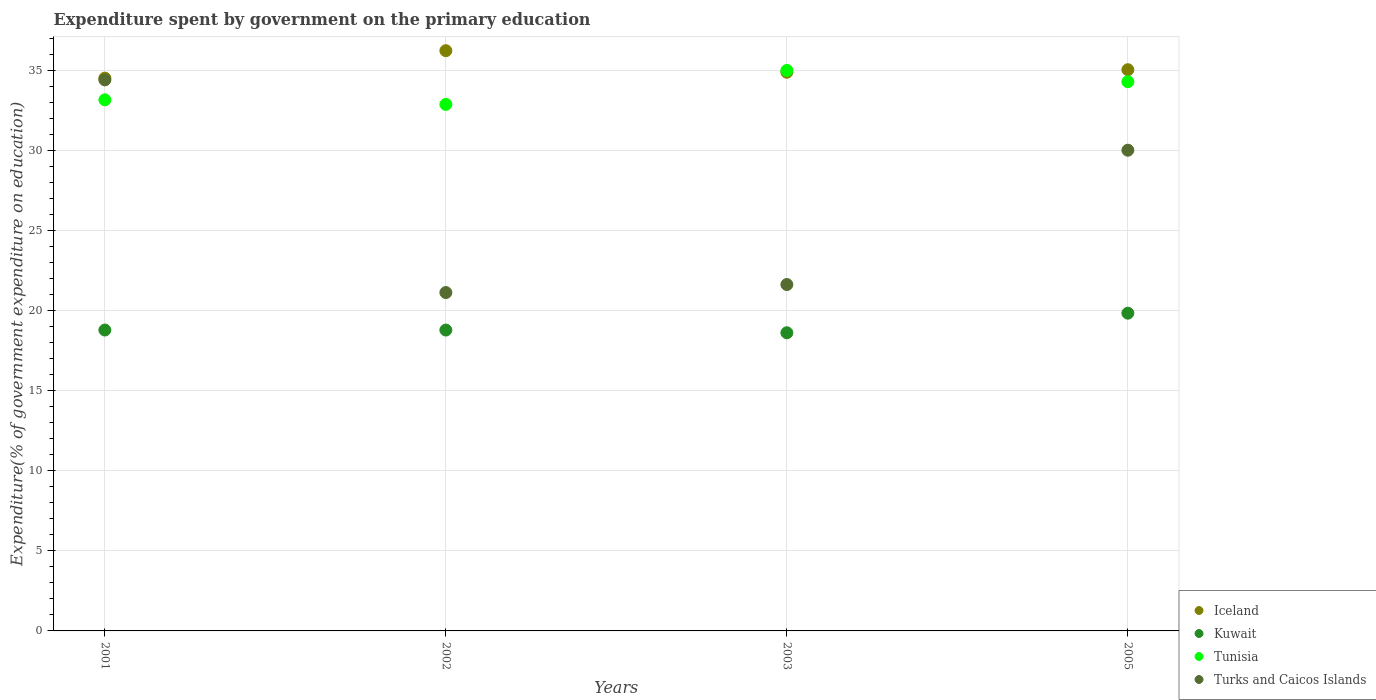How many different coloured dotlines are there?
Your answer should be very brief. 4. What is the expenditure spent by government on the primary education in Kuwait in 2005?
Your answer should be very brief. 19.83. Across all years, what is the maximum expenditure spent by government on the primary education in Kuwait?
Make the answer very short. 19.83. Across all years, what is the minimum expenditure spent by government on the primary education in Iceland?
Give a very brief answer. 34.5. In which year was the expenditure spent by government on the primary education in Iceland minimum?
Provide a short and direct response. 2001. What is the total expenditure spent by government on the primary education in Turks and Caicos Islands in the graph?
Keep it short and to the point. 107.13. What is the difference between the expenditure spent by government on the primary education in Turks and Caicos Islands in 2002 and that in 2005?
Offer a terse response. -8.88. What is the difference between the expenditure spent by government on the primary education in Kuwait in 2002 and the expenditure spent by government on the primary education in Turks and Caicos Islands in 2005?
Give a very brief answer. -11.22. What is the average expenditure spent by government on the primary education in Turks and Caicos Islands per year?
Make the answer very short. 26.78. In the year 2001, what is the difference between the expenditure spent by government on the primary education in Tunisia and expenditure spent by government on the primary education in Iceland?
Provide a succinct answer. -1.36. What is the ratio of the expenditure spent by government on the primary education in Kuwait in 2002 to that in 2005?
Keep it short and to the point. 0.95. Is the expenditure spent by government on the primary education in Iceland in 2001 less than that in 2005?
Keep it short and to the point. Yes. What is the difference between the highest and the second highest expenditure spent by government on the primary education in Tunisia?
Provide a short and direct response. 0.7. What is the difference between the highest and the lowest expenditure spent by government on the primary education in Iceland?
Your answer should be very brief. 1.71. In how many years, is the expenditure spent by government on the primary education in Iceland greater than the average expenditure spent by government on the primary education in Iceland taken over all years?
Give a very brief answer. 1. Is the expenditure spent by government on the primary education in Kuwait strictly less than the expenditure spent by government on the primary education in Turks and Caicos Islands over the years?
Ensure brevity in your answer.  Yes. How many dotlines are there?
Your answer should be very brief. 4. What is the difference between two consecutive major ticks on the Y-axis?
Your answer should be very brief. 5. Does the graph contain any zero values?
Make the answer very short. No. Where does the legend appear in the graph?
Your response must be concise. Bottom right. How are the legend labels stacked?
Ensure brevity in your answer.  Vertical. What is the title of the graph?
Offer a terse response. Expenditure spent by government on the primary education. Does "High income: nonOECD" appear as one of the legend labels in the graph?
Make the answer very short. No. What is the label or title of the X-axis?
Offer a very short reply. Years. What is the label or title of the Y-axis?
Provide a short and direct response. Expenditure(% of government expenditure on education). What is the Expenditure(% of government expenditure on education) of Iceland in 2001?
Give a very brief answer. 34.5. What is the Expenditure(% of government expenditure on education) of Kuwait in 2001?
Keep it short and to the point. 18.78. What is the Expenditure(% of government expenditure on education) of Tunisia in 2001?
Ensure brevity in your answer.  33.15. What is the Expenditure(% of government expenditure on education) of Turks and Caicos Islands in 2001?
Offer a terse response. 34.39. What is the Expenditure(% of government expenditure on education) of Iceland in 2002?
Ensure brevity in your answer.  36.21. What is the Expenditure(% of government expenditure on education) in Kuwait in 2002?
Keep it short and to the point. 18.78. What is the Expenditure(% of government expenditure on education) of Tunisia in 2002?
Give a very brief answer. 32.86. What is the Expenditure(% of government expenditure on education) in Turks and Caicos Islands in 2002?
Your response must be concise. 21.12. What is the Expenditure(% of government expenditure on education) of Iceland in 2003?
Provide a short and direct response. 34.87. What is the Expenditure(% of government expenditure on education) of Kuwait in 2003?
Your answer should be compact. 18.61. What is the Expenditure(% of government expenditure on education) in Tunisia in 2003?
Your answer should be very brief. 34.98. What is the Expenditure(% of government expenditure on education) in Turks and Caicos Islands in 2003?
Your answer should be very brief. 21.62. What is the Expenditure(% of government expenditure on education) in Iceland in 2005?
Your answer should be very brief. 35.03. What is the Expenditure(% of government expenditure on education) of Kuwait in 2005?
Offer a very short reply. 19.83. What is the Expenditure(% of government expenditure on education) of Tunisia in 2005?
Keep it short and to the point. 34.28. What is the Expenditure(% of government expenditure on education) of Turks and Caicos Islands in 2005?
Offer a terse response. 30. Across all years, what is the maximum Expenditure(% of government expenditure on education) in Iceland?
Offer a terse response. 36.21. Across all years, what is the maximum Expenditure(% of government expenditure on education) of Kuwait?
Ensure brevity in your answer.  19.83. Across all years, what is the maximum Expenditure(% of government expenditure on education) in Tunisia?
Give a very brief answer. 34.98. Across all years, what is the maximum Expenditure(% of government expenditure on education) of Turks and Caicos Islands?
Ensure brevity in your answer.  34.39. Across all years, what is the minimum Expenditure(% of government expenditure on education) of Iceland?
Provide a short and direct response. 34.5. Across all years, what is the minimum Expenditure(% of government expenditure on education) of Kuwait?
Your answer should be compact. 18.61. Across all years, what is the minimum Expenditure(% of government expenditure on education) in Tunisia?
Offer a very short reply. 32.86. Across all years, what is the minimum Expenditure(% of government expenditure on education) in Turks and Caicos Islands?
Ensure brevity in your answer.  21.12. What is the total Expenditure(% of government expenditure on education) in Iceland in the graph?
Ensure brevity in your answer.  140.61. What is the total Expenditure(% of government expenditure on education) in Kuwait in the graph?
Ensure brevity in your answer.  76. What is the total Expenditure(% of government expenditure on education) in Tunisia in the graph?
Ensure brevity in your answer.  135.26. What is the total Expenditure(% of government expenditure on education) in Turks and Caicos Islands in the graph?
Give a very brief answer. 107.13. What is the difference between the Expenditure(% of government expenditure on education) of Iceland in 2001 and that in 2002?
Your answer should be very brief. -1.71. What is the difference between the Expenditure(% of government expenditure on education) of Kuwait in 2001 and that in 2002?
Ensure brevity in your answer.  0. What is the difference between the Expenditure(% of government expenditure on education) in Tunisia in 2001 and that in 2002?
Your answer should be very brief. 0.29. What is the difference between the Expenditure(% of government expenditure on education) of Turks and Caicos Islands in 2001 and that in 2002?
Keep it short and to the point. 13.27. What is the difference between the Expenditure(% of government expenditure on education) of Iceland in 2001 and that in 2003?
Give a very brief answer. -0.37. What is the difference between the Expenditure(% of government expenditure on education) in Kuwait in 2001 and that in 2003?
Make the answer very short. 0.17. What is the difference between the Expenditure(% of government expenditure on education) of Tunisia in 2001 and that in 2003?
Make the answer very short. -1.83. What is the difference between the Expenditure(% of government expenditure on education) of Turks and Caicos Islands in 2001 and that in 2003?
Give a very brief answer. 12.77. What is the difference between the Expenditure(% of government expenditure on education) in Iceland in 2001 and that in 2005?
Your answer should be very brief. -0.52. What is the difference between the Expenditure(% of government expenditure on education) in Kuwait in 2001 and that in 2005?
Provide a short and direct response. -1.05. What is the difference between the Expenditure(% of government expenditure on education) of Tunisia in 2001 and that in 2005?
Ensure brevity in your answer.  -1.13. What is the difference between the Expenditure(% of government expenditure on education) in Turks and Caicos Islands in 2001 and that in 2005?
Give a very brief answer. 4.39. What is the difference between the Expenditure(% of government expenditure on education) in Iceland in 2002 and that in 2003?
Provide a succinct answer. 1.34. What is the difference between the Expenditure(% of government expenditure on education) in Kuwait in 2002 and that in 2003?
Ensure brevity in your answer.  0.17. What is the difference between the Expenditure(% of government expenditure on education) of Tunisia in 2002 and that in 2003?
Offer a terse response. -2.12. What is the difference between the Expenditure(% of government expenditure on education) in Turks and Caicos Islands in 2002 and that in 2003?
Make the answer very short. -0.5. What is the difference between the Expenditure(% of government expenditure on education) of Iceland in 2002 and that in 2005?
Your response must be concise. 1.19. What is the difference between the Expenditure(% of government expenditure on education) in Kuwait in 2002 and that in 2005?
Offer a terse response. -1.05. What is the difference between the Expenditure(% of government expenditure on education) in Tunisia in 2002 and that in 2005?
Your answer should be compact. -1.42. What is the difference between the Expenditure(% of government expenditure on education) of Turks and Caicos Islands in 2002 and that in 2005?
Offer a very short reply. -8.88. What is the difference between the Expenditure(% of government expenditure on education) in Iceland in 2003 and that in 2005?
Ensure brevity in your answer.  -0.16. What is the difference between the Expenditure(% of government expenditure on education) in Kuwait in 2003 and that in 2005?
Your answer should be very brief. -1.22. What is the difference between the Expenditure(% of government expenditure on education) in Tunisia in 2003 and that in 2005?
Make the answer very short. 0.7. What is the difference between the Expenditure(% of government expenditure on education) of Turks and Caicos Islands in 2003 and that in 2005?
Make the answer very short. -8.38. What is the difference between the Expenditure(% of government expenditure on education) in Iceland in 2001 and the Expenditure(% of government expenditure on education) in Kuwait in 2002?
Offer a terse response. 15.72. What is the difference between the Expenditure(% of government expenditure on education) of Iceland in 2001 and the Expenditure(% of government expenditure on education) of Tunisia in 2002?
Your response must be concise. 1.64. What is the difference between the Expenditure(% of government expenditure on education) of Iceland in 2001 and the Expenditure(% of government expenditure on education) of Turks and Caicos Islands in 2002?
Ensure brevity in your answer.  13.38. What is the difference between the Expenditure(% of government expenditure on education) in Kuwait in 2001 and the Expenditure(% of government expenditure on education) in Tunisia in 2002?
Offer a very short reply. -14.08. What is the difference between the Expenditure(% of government expenditure on education) of Kuwait in 2001 and the Expenditure(% of government expenditure on education) of Turks and Caicos Islands in 2002?
Your answer should be very brief. -2.34. What is the difference between the Expenditure(% of government expenditure on education) in Tunisia in 2001 and the Expenditure(% of government expenditure on education) in Turks and Caicos Islands in 2002?
Offer a terse response. 12.03. What is the difference between the Expenditure(% of government expenditure on education) of Iceland in 2001 and the Expenditure(% of government expenditure on education) of Kuwait in 2003?
Give a very brief answer. 15.89. What is the difference between the Expenditure(% of government expenditure on education) of Iceland in 2001 and the Expenditure(% of government expenditure on education) of Tunisia in 2003?
Offer a very short reply. -0.48. What is the difference between the Expenditure(% of government expenditure on education) of Iceland in 2001 and the Expenditure(% of government expenditure on education) of Turks and Caicos Islands in 2003?
Make the answer very short. 12.88. What is the difference between the Expenditure(% of government expenditure on education) of Kuwait in 2001 and the Expenditure(% of government expenditure on education) of Tunisia in 2003?
Provide a succinct answer. -16.2. What is the difference between the Expenditure(% of government expenditure on education) of Kuwait in 2001 and the Expenditure(% of government expenditure on education) of Turks and Caicos Islands in 2003?
Your response must be concise. -2.84. What is the difference between the Expenditure(% of government expenditure on education) in Tunisia in 2001 and the Expenditure(% of government expenditure on education) in Turks and Caicos Islands in 2003?
Your answer should be very brief. 11.53. What is the difference between the Expenditure(% of government expenditure on education) in Iceland in 2001 and the Expenditure(% of government expenditure on education) in Kuwait in 2005?
Keep it short and to the point. 14.67. What is the difference between the Expenditure(% of government expenditure on education) in Iceland in 2001 and the Expenditure(% of government expenditure on education) in Tunisia in 2005?
Provide a short and direct response. 0.22. What is the difference between the Expenditure(% of government expenditure on education) in Iceland in 2001 and the Expenditure(% of government expenditure on education) in Turks and Caicos Islands in 2005?
Provide a short and direct response. 4.5. What is the difference between the Expenditure(% of government expenditure on education) of Kuwait in 2001 and the Expenditure(% of government expenditure on education) of Tunisia in 2005?
Keep it short and to the point. -15.5. What is the difference between the Expenditure(% of government expenditure on education) in Kuwait in 2001 and the Expenditure(% of government expenditure on education) in Turks and Caicos Islands in 2005?
Provide a short and direct response. -11.22. What is the difference between the Expenditure(% of government expenditure on education) in Tunisia in 2001 and the Expenditure(% of government expenditure on education) in Turks and Caicos Islands in 2005?
Offer a terse response. 3.14. What is the difference between the Expenditure(% of government expenditure on education) of Iceland in 2002 and the Expenditure(% of government expenditure on education) of Kuwait in 2003?
Give a very brief answer. 17.61. What is the difference between the Expenditure(% of government expenditure on education) of Iceland in 2002 and the Expenditure(% of government expenditure on education) of Tunisia in 2003?
Your answer should be very brief. 1.23. What is the difference between the Expenditure(% of government expenditure on education) in Iceland in 2002 and the Expenditure(% of government expenditure on education) in Turks and Caicos Islands in 2003?
Offer a very short reply. 14.59. What is the difference between the Expenditure(% of government expenditure on education) of Kuwait in 2002 and the Expenditure(% of government expenditure on education) of Tunisia in 2003?
Your answer should be very brief. -16.2. What is the difference between the Expenditure(% of government expenditure on education) in Kuwait in 2002 and the Expenditure(% of government expenditure on education) in Turks and Caicos Islands in 2003?
Your answer should be compact. -2.84. What is the difference between the Expenditure(% of government expenditure on education) in Tunisia in 2002 and the Expenditure(% of government expenditure on education) in Turks and Caicos Islands in 2003?
Offer a very short reply. 11.24. What is the difference between the Expenditure(% of government expenditure on education) of Iceland in 2002 and the Expenditure(% of government expenditure on education) of Kuwait in 2005?
Provide a succinct answer. 16.38. What is the difference between the Expenditure(% of government expenditure on education) in Iceland in 2002 and the Expenditure(% of government expenditure on education) in Tunisia in 2005?
Make the answer very short. 1.94. What is the difference between the Expenditure(% of government expenditure on education) in Iceland in 2002 and the Expenditure(% of government expenditure on education) in Turks and Caicos Islands in 2005?
Provide a short and direct response. 6.21. What is the difference between the Expenditure(% of government expenditure on education) in Kuwait in 2002 and the Expenditure(% of government expenditure on education) in Tunisia in 2005?
Make the answer very short. -15.5. What is the difference between the Expenditure(% of government expenditure on education) in Kuwait in 2002 and the Expenditure(% of government expenditure on education) in Turks and Caicos Islands in 2005?
Your answer should be compact. -11.22. What is the difference between the Expenditure(% of government expenditure on education) in Tunisia in 2002 and the Expenditure(% of government expenditure on education) in Turks and Caicos Islands in 2005?
Your answer should be compact. 2.86. What is the difference between the Expenditure(% of government expenditure on education) in Iceland in 2003 and the Expenditure(% of government expenditure on education) in Kuwait in 2005?
Your response must be concise. 15.04. What is the difference between the Expenditure(% of government expenditure on education) in Iceland in 2003 and the Expenditure(% of government expenditure on education) in Tunisia in 2005?
Your answer should be compact. 0.59. What is the difference between the Expenditure(% of government expenditure on education) in Iceland in 2003 and the Expenditure(% of government expenditure on education) in Turks and Caicos Islands in 2005?
Offer a terse response. 4.87. What is the difference between the Expenditure(% of government expenditure on education) in Kuwait in 2003 and the Expenditure(% of government expenditure on education) in Tunisia in 2005?
Make the answer very short. -15.67. What is the difference between the Expenditure(% of government expenditure on education) in Kuwait in 2003 and the Expenditure(% of government expenditure on education) in Turks and Caicos Islands in 2005?
Ensure brevity in your answer.  -11.39. What is the difference between the Expenditure(% of government expenditure on education) of Tunisia in 2003 and the Expenditure(% of government expenditure on education) of Turks and Caicos Islands in 2005?
Your answer should be compact. 4.98. What is the average Expenditure(% of government expenditure on education) of Iceland per year?
Give a very brief answer. 35.15. What is the average Expenditure(% of government expenditure on education) in Kuwait per year?
Give a very brief answer. 19. What is the average Expenditure(% of government expenditure on education) in Tunisia per year?
Your response must be concise. 33.82. What is the average Expenditure(% of government expenditure on education) of Turks and Caicos Islands per year?
Ensure brevity in your answer.  26.78. In the year 2001, what is the difference between the Expenditure(% of government expenditure on education) in Iceland and Expenditure(% of government expenditure on education) in Kuwait?
Offer a terse response. 15.72. In the year 2001, what is the difference between the Expenditure(% of government expenditure on education) of Iceland and Expenditure(% of government expenditure on education) of Tunisia?
Make the answer very short. 1.36. In the year 2001, what is the difference between the Expenditure(% of government expenditure on education) of Iceland and Expenditure(% of government expenditure on education) of Turks and Caicos Islands?
Ensure brevity in your answer.  0.11. In the year 2001, what is the difference between the Expenditure(% of government expenditure on education) in Kuwait and Expenditure(% of government expenditure on education) in Tunisia?
Make the answer very short. -14.37. In the year 2001, what is the difference between the Expenditure(% of government expenditure on education) of Kuwait and Expenditure(% of government expenditure on education) of Turks and Caicos Islands?
Make the answer very short. -15.61. In the year 2001, what is the difference between the Expenditure(% of government expenditure on education) in Tunisia and Expenditure(% of government expenditure on education) in Turks and Caicos Islands?
Ensure brevity in your answer.  -1.24. In the year 2002, what is the difference between the Expenditure(% of government expenditure on education) in Iceland and Expenditure(% of government expenditure on education) in Kuwait?
Offer a terse response. 17.44. In the year 2002, what is the difference between the Expenditure(% of government expenditure on education) in Iceland and Expenditure(% of government expenditure on education) in Tunisia?
Offer a terse response. 3.35. In the year 2002, what is the difference between the Expenditure(% of government expenditure on education) of Iceland and Expenditure(% of government expenditure on education) of Turks and Caicos Islands?
Your answer should be very brief. 15.1. In the year 2002, what is the difference between the Expenditure(% of government expenditure on education) of Kuwait and Expenditure(% of government expenditure on education) of Tunisia?
Give a very brief answer. -14.08. In the year 2002, what is the difference between the Expenditure(% of government expenditure on education) in Kuwait and Expenditure(% of government expenditure on education) in Turks and Caicos Islands?
Offer a very short reply. -2.34. In the year 2002, what is the difference between the Expenditure(% of government expenditure on education) of Tunisia and Expenditure(% of government expenditure on education) of Turks and Caicos Islands?
Make the answer very short. 11.74. In the year 2003, what is the difference between the Expenditure(% of government expenditure on education) of Iceland and Expenditure(% of government expenditure on education) of Kuwait?
Offer a very short reply. 16.26. In the year 2003, what is the difference between the Expenditure(% of government expenditure on education) in Iceland and Expenditure(% of government expenditure on education) in Tunisia?
Your answer should be very brief. -0.11. In the year 2003, what is the difference between the Expenditure(% of government expenditure on education) in Iceland and Expenditure(% of government expenditure on education) in Turks and Caicos Islands?
Provide a short and direct response. 13.25. In the year 2003, what is the difference between the Expenditure(% of government expenditure on education) in Kuwait and Expenditure(% of government expenditure on education) in Tunisia?
Offer a very short reply. -16.37. In the year 2003, what is the difference between the Expenditure(% of government expenditure on education) in Kuwait and Expenditure(% of government expenditure on education) in Turks and Caicos Islands?
Ensure brevity in your answer.  -3.01. In the year 2003, what is the difference between the Expenditure(% of government expenditure on education) in Tunisia and Expenditure(% of government expenditure on education) in Turks and Caicos Islands?
Provide a succinct answer. 13.36. In the year 2005, what is the difference between the Expenditure(% of government expenditure on education) in Iceland and Expenditure(% of government expenditure on education) in Kuwait?
Keep it short and to the point. 15.19. In the year 2005, what is the difference between the Expenditure(% of government expenditure on education) of Iceland and Expenditure(% of government expenditure on education) of Tunisia?
Ensure brevity in your answer.  0.75. In the year 2005, what is the difference between the Expenditure(% of government expenditure on education) in Iceland and Expenditure(% of government expenditure on education) in Turks and Caicos Islands?
Keep it short and to the point. 5.02. In the year 2005, what is the difference between the Expenditure(% of government expenditure on education) in Kuwait and Expenditure(% of government expenditure on education) in Tunisia?
Provide a short and direct response. -14.45. In the year 2005, what is the difference between the Expenditure(% of government expenditure on education) of Kuwait and Expenditure(% of government expenditure on education) of Turks and Caicos Islands?
Keep it short and to the point. -10.17. In the year 2005, what is the difference between the Expenditure(% of government expenditure on education) in Tunisia and Expenditure(% of government expenditure on education) in Turks and Caicos Islands?
Keep it short and to the point. 4.28. What is the ratio of the Expenditure(% of government expenditure on education) in Iceland in 2001 to that in 2002?
Provide a short and direct response. 0.95. What is the ratio of the Expenditure(% of government expenditure on education) in Kuwait in 2001 to that in 2002?
Provide a short and direct response. 1. What is the ratio of the Expenditure(% of government expenditure on education) of Tunisia in 2001 to that in 2002?
Your response must be concise. 1.01. What is the ratio of the Expenditure(% of government expenditure on education) of Turks and Caicos Islands in 2001 to that in 2002?
Give a very brief answer. 1.63. What is the ratio of the Expenditure(% of government expenditure on education) in Kuwait in 2001 to that in 2003?
Your answer should be very brief. 1.01. What is the ratio of the Expenditure(% of government expenditure on education) in Tunisia in 2001 to that in 2003?
Offer a very short reply. 0.95. What is the ratio of the Expenditure(% of government expenditure on education) of Turks and Caicos Islands in 2001 to that in 2003?
Make the answer very short. 1.59. What is the ratio of the Expenditure(% of government expenditure on education) of Kuwait in 2001 to that in 2005?
Your response must be concise. 0.95. What is the ratio of the Expenditure(% of government expenditure on education) in Tunisia in 2001 to that in 2005?
Offer a terse response. 0.97. What is the ratio of the Expenditure(% of government expenditure on education) of Turks and Caicos Islands in 2001 to that in 2005?
Give a very brief answer. 1.15. What is the ratio of the Expenditure(% of government expenditure on education) of Iceland in 2002 to that in 2003?
Your response must be concise. 1.04. What is the ratio of the Expenditure(% of government expenditure on education) of Kuwait in 2002 to that in 2003?
Your response must be concise. 1.01. What is the ratio of the Expenditure(% of government expenditure on education) in Tunisia in 2002 to that in 2003?
Your response must be concise. 0.94. What is the ratio of the Expenditure(% of government expenditure on education) of Turks and Caicos Islands in 2002 to that in 2003?
Keep it short and to the point. 0.98. What is the ratio of the Expenditure(% of government expenditure on education) of Iceland in 2002 to that in 2005?
Offer a very short reply. 1.03. What is the ratio of the Expenditure(% of government expenditure on education) of Kuwait in 2002 to that in 2005?
Offer a terse response. 0.95. What is the ratio of the Expenditure(% of government expenditure on education) of Tunisia in 2002 to that in 2005?
Give a very brief answer. 0.96. What is the ratio of the Expenditure(% of government expenditure on education) in Turks and Caicos Islands in 2002 to that in 2005?
Provide a succinct answer. 0.7. What is the ratio of the Expenditure(% of government expenditure on education) in Iceland in 2003 to that in 2005?
Provide a succinct answer. 1. What is the ratio of the Expenditure(% of government expenditure on education) of Kuwait in 2003 to that in 2005?
Your answer should be very brief. 0.94. What is the ratio of the Expenditure(% of government expenditure on education) in Tunisia in 2003 to that in 2005?
Provide a succinct answer. 1.02. What is the ratio of the Expenditure(% of government expenditure on education) of Turks and Caicos Islands in 2003 to that in 2005?
Offer a terse response. 0.72. What is the difference between the highest and the second highest Expenditure(% of government expenditure on education) in Iceland?
Provide a succinct answer. 1.19. What is the difference between the highest and the second highest Expenditure(% of government expenditure on education) in Kuwait?
Provide a succinct answer. 1.05. What is the difference between the highest and the second highest Expenditure(% of government expenditure on education) of Tunisia?
Keep it short and to the point. 0.7. What is the difference between the highest and the second highest Expenditure(% of government expenditure on education) of Turks and Caicos Islands?
Your answer should be very brief. 4.39. What is the difference between the highest and the lowest Expenditure(% of government expenditure on education) in Iceland?
Provide a short and direct response. 1.71. What is the difference between the highest and the lowest Expenditure(% of government expenditure on education) in Kuwait?
Offer a very short reply. 1.22. What is the difference between the highest and the lowest Expenditure(% of government expenditure on education) of Tunisia?
Your answer should be very brief. 2.12. What is the difference between the highest and the lowest Expenditure(% of government expenditure on education) in Turks and Caicos Islands?
Your answer should be very brief. 13.27. 